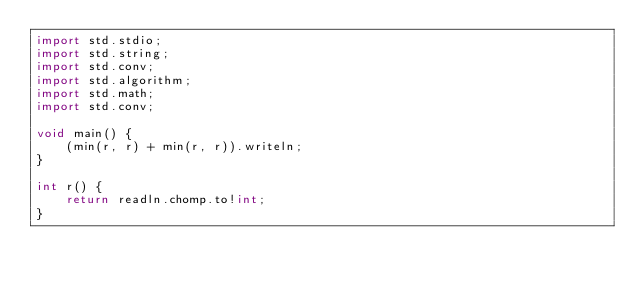<code> <loc_0><loc_0><loc_500><loc_500><_D_>import std.stdio;
import std.string;
import std.conv;
import std.algorithm;
import std.math;
import std.conv;

void main() {
	(min(r, r) + min(r, r)).writeln;
}

int r() {
	return readln.chomp.to!int;
}</code> 